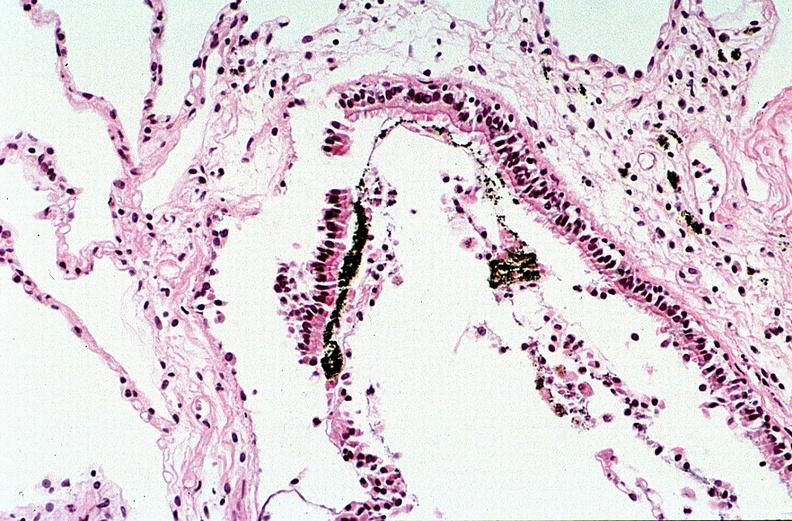do mucicarmine burn?
Answer the question using a single word or phrase. No 